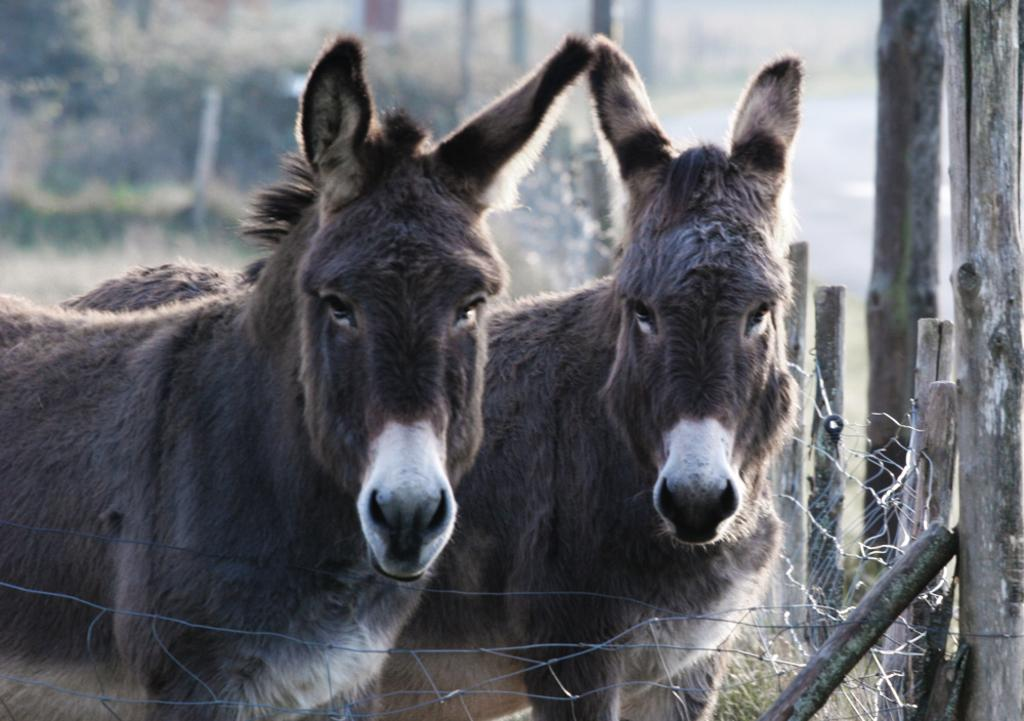What animals are in the center of the image? There are donkeys in the center of the image. What structure is on the right side of the image? There is a mesh and poles on the right side of the image. What can be seen in the background of the image? There are trees visible in the background of the image. Where can the rest of the donkeys be found in the image? There is no mention of other donkeys in the image, so it is not possible to determine where the rest of the donkeys might be found. 